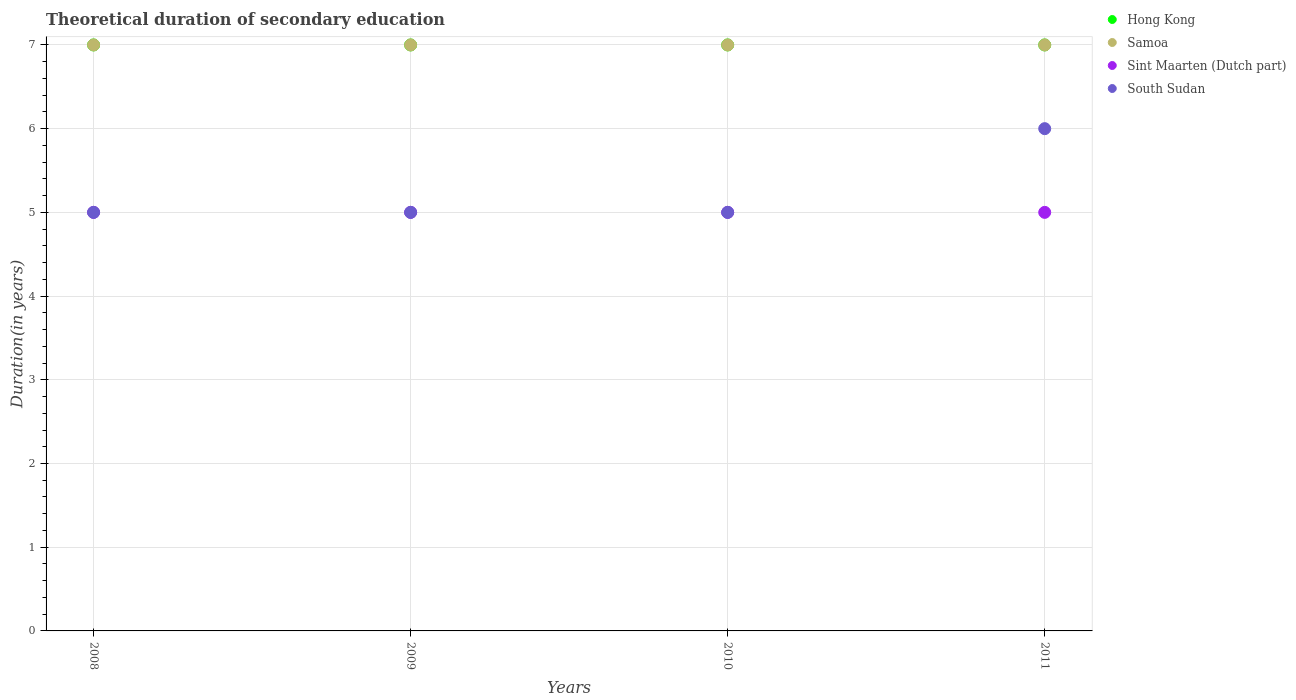Is the number of dotlines equal to the number of legend labels?
Make the answer very short. Yes. What is the total theoretical duration of secondary education in Sint Maarten (Dutch part) in 2011?
Make the answer very short. 5. Across all years, what is the maximum total theoretical duration of secondary education in South Sudan?
Offer a terse response. 6. What is the total total theoretical duration of secondary education in South Sudan in the graph?
Make the answer very short. 21. What is the difference between the total theoretical duration of secondary education in Sint Maarten (Dutch part) in 2011 and the total theoretical duration of secondary education in Samoa in 2009?
Ensure brevity in your answer.  -2. What is the average total theoretical duration of secondary education in South Sudan per year?
Offer a terse response. 5.25. In the year 2009, what is the difference between the total theoretical duration of secondary education in Sint Maarten (Dutch part) and total theoretical duration of secondary education in Samoa?
Give a very brief answer. -2. In how many years, is the total theoretical duration of secondary education in Sint Maarten (Dutch part) greater than 4.4 years?
Your answer should be compact. 4. What is the ratio of the total theoretical duration of secondary education in Sint Maarten (Dutch part) in 2010 to that in 2011?
Offer a terse response. 1. Is the difference between the total theoretical duration of secondary education in Sint Maarten (Dutch part) in 2008 and 2011 greater than the difference between the total theoretical duration of secondary education in Samoa in 2008 and 2011?
Offer a very short reply. No. What is the difference between the highest and the second highest total theoretical duration of secondary education in Samoa?
Keep it short and to the point. 0. In how many years, is the total theoretical duration of secondary education in Samoa greater than the average total theoretical duration of secondary education in Samoa taken over all years?
Give a very brief answer. 0. Is it the case that in every year, the sum of the total theoretical duration of secondary education in Hong Kong and total theoretical duration of secondary education in Samoa  is greater than the total theoretical duration of secondary education in Sint Maarten (Dutch part)?
Ensure brevity in your answer.  Yes. How many years are there in the graph?
Provide a short and direct response. 4. What is the difference between two consecutive major ticks on the Y-axis?
Make the answer very short. 1. Are the values on the major ticks of Y-axis written in scientific E-notation?
Your response must be concise. No. Does the graph contain grids?
Offer a very short reply. Yes. How are the legend labels stacked?
Your response must be concise. Vertical. What is the title of the graph?
Keep it short and to the point. Theoretical duration of secondary education. What is the label or title of the X-axis?
Offer a very short reply. Years. What is the label or title of the Y-axis?
Keep it short and to the point. Duration(in years). What is the Duration(in years) in South Sudan in 2008?
Keep it short and to the point. 5. What is the Duration(in years) of Hong Kong in 2010?
Your answer should be compact. 7. What is the Duration(in years) in South Sudan in 2010?
Offer a terse response. 5. What is the Duration(in years) of South Sudan in 2011?
Make the answer very short. 6. Across all years, what is the maximum Duration(in years) of Hong Kong?
Make the answer very short. 7. Across all years, what is the maximum Duration(in years) of Sint Maarten (Dutch part)?
Your answer should be very brief. 5. Across all years, what is the maximum Duration(in years) of South Sudan?
Your answer should be compact. 6. What is the difference between the Duration(in years) in Hong Kong in 2008 and that in 2009?
Your answer should be very brief. 0. What is the difference between the Duration(in years) in Samoa in 2008 and that in 2009?
Your response must be concise. 0. What is the difference between the Duration(in years) in South Sudan in 2008 and that in 2009?
Provide a succinct answer. 0. What is the difference between the Duration(in years) of Hong Kong in 2008 and that in 2010?
Your answer should be very brief. 0. What is the difference between the Duration(in years) of Sint Maarten (Dutch part) in 2008 and that in 2010?
Provide a succinct answer. 0. What is the difference between the Duration(in years) of Hong Kong in 2008 and that in 2011?
Provide a short and direct response. 0. What is the difference between the Duration(in years) of Sint Maarten (Dutch part) in 2008 and that in 2011?
Ensure brevity in your answer.  0. What is the difference between the Duration(in years) of Hong Kong in 2009 and that in 2010?
Your answer should be compact. 0. What is the difference between the Duration(in years) of Sint Maarten (Dutch part) in 2009 and that in 2010?
Ensure brevity in your answer.  0. What is the difference between the Duration(in years) in Samoa in 2009 and that in 2011?
Offer a very short reply. 0. What is the difference between the Duration(in years) of South Sudan in 2009 and that in 2011?
Offer a very short reply. -1. What is the difference between the Duration(in years) of Samoa in 2010 and that in 2011?
Ensure brevity in your answer.  0. What is the difference between the Duration(in years) of South Sudan in 2010 and that in 2011?
Your answer should be compact. -1. What is the difference between the Duration(in years) of Hong Kong in 2008 and the Duration(in years) of Samoa in 2009?
Keep it short and to the point. 0. What is the difference between the Duration(in years) in Sint Maarten (Dutch part) in 2008 and the Duration(in years) in South Sudan in 2009?
Provide a short and direct response. 0. What is the difference between the Duration(in years) of Sint Maarten (Dutch part) in 2008 and the Duration(in years) of South Sudan in 2010?
Keep it short and to the point. 0. What is the difference between the Duration(in years) of Hong Kong in 2008 and the Duration(in years) of South Sudan in 2011?
Your answer should be very brief. 1. What is the difference between the Duration(in years) of Samoa in 2008 and the Duration(in years) of Sint Maarten (Dutch part) in 2011?
Your answer should be compact. 2. What is the difference between the Duration(in years) of Samoa in 2008 and the Duration(in years) of South Sudan in 2011?
Provide a succinct answer. 1. What is the difference between the Duration(in years) in Sint Maarten (Dutch part) in 2008 and the Duration(in years) in South Sudan in 2011?
Offer a very short reply. -1. What is the difference between the Duration(in years) of Hong Kong in 2009 and the Duration(in years) of Samoa in 2010?
Give a very brief answer. 0. What is the difference between the Duration(in years) of Hong Kong in 2009 and the Duration(in years) of Sint Maarten (Dutch part) in 2010?
Provide a short and direct response. 2. What is the difference between the Duration(in years) in Hong Kong in 2009 and the Duration(in years) in South Sudan in 2010?
Your answer should be very brief. 2. What is the difference between the Duration(in years) of Samoa in 2009 and the Duration(in years) of Sint Maarten (Dutch part) in 2010?
Your answer should be very brief. 2. What is the difference between the Duration(in years) of Samoa in 2009 and the Duration(in years) of South Sudan in 2010?
Offer a terse response. 2. What is the difference between the Duration(in years) of Hong Kong in 2009 and the Duration(in years) of Samoa in 2011?
Your answer should be very brief. 0. What is the difference between the Duration(in years) in Hong Kong in 2009 and the Duration(in years) in Sint Maarten (Dutch part) in 2011?
Ensure brevity in your answer.  2. What is the difference between the Duration(in years) of Sint Maarten (Dutch part) in 2009 and the Duration(in years) of South Sudan in 2011?
Your response must be concise. -1. What is the difference between the Duration(in years) of Hong Kong in 2010 and the Duration(in years) of Samoa in 2011?
Give a very brief answer. 0. What is the difference between the Duration(in years) in Hong Kong in 2010 and the Duration(in years) in Sint Maarten (Dutch part) in 2011?
Your answer should be very brief. 2. What is the difference between the Duration(in years) in Samoa in 2010 and the Duration(in years) in South Sudan in 2011?
Your answer should be very brief. 1. What is the average Duration(in years) of Hong Kong per year?
Provide a succinct answer. 7. What is the average Duration(in years) in Samoa per year?
Make the answer very short. 7. What is the average Duration(in years) of South Sudan per year?
Ensure brevity in your answer.  5.25. In the year 2008, what is the difference between the Duration(in years) of Hong Kong and Duration(in years) of Samoa?
Provide a short and direct response. 0. In the year 2008, what is the difference between the Duration(in years) of Hong Kong and Duration(in years) of Sint Maarten (Dutch part)?
Provide a short and direct response. 2. In the year 2008, what is the difference between the Duration(in years) in Samoa and Duration(in years) in Sint Maarten (Dutch part)?
Your answer should be very brief. 2. In the year 2008, what is the difference between the Duration(in years) of Samoa and Duration(in years) of South Sudan?
Give a very brief answer. 2. In the year 2009, what is the difference between the Duration(in years) of Hong Kong and Duration(in years) of South Sudan?
Ensure brevity in your answer.  2. In the year 2009, what is the difference between the Duration(in years) in Samoa and Duration(in years) in South Sudan?
Your answer should be very brief. 2. In the year 2009, what is the difference between the Duration(in years) of Sint Maarten (Dutch part) and Duration(in years) of South Sudan?
Offer a very short reply. 0. In the year 2010, what is the difference between the Duration(in years) of Hong Kong and Duration(in years) of Samoa?
Provide a succinct answer. 0. In the year 2010, what is the difference between the Duration(in years) in Hong Kong and Duration(in years) in Sint Maarten (Dutch part)?
Keep it short and to the point. 2. In the year 2011, what is the difference between the Duration(in years) of Hong Kong and Duration(in years) of Sint Maarten (Dutch part)?
Provide a succinct answer. 2. What is the ratio of the Duration(in years) of Hong Kong in 2008 to that in 2009?
Give a very brief answer. 1. What is the ratio of the Duration(in years) of Sint Maarten (Dutch part) in 2008 to that in 2009?
Ensure brevity in your answer.  1. What is the ratio of the Duration(in years) of South Sudan in 2008 to that in 2009?
Provide a succinct answer. 1. What is the ratio of the Duration(in years) in Hong Kong in 2008 to that in 2010?
Provide a succinct answer. 1. What is the ratio of the Duration(in years) of Hong Kong in 2008 to that in 2011?
Provide a short and direct response. 1. What is the ratio of the Duration(in years) in Samoa in 2008 to that in 2011?
Ensure brevity in your answer.  1. What is the ratio of the Duration(in years) in Sint Maarten (Dutch part) in 2008 to that in 2011?
Your answer should be very brief. 1. What is the ratio of the Duration(in years) of South Sudan in 2008 to that in 2011?
Keep it short and to the point. 0.83. What is the ratio of the Duration(in years) of Hong Kong in 2009 to that in 2010?
Offer a terse response. 1. What is the ratio of the Duration(in years) in Sint Maarten (Dutch part) in 2009 to that in 2010?
Offer a terse response. 1. What is the ratio of the Duration(in years) of Samoa in 2009 to that in 2011?
Give a very brief answer. 1. What is the ratio of the Duration(in years) of Sint Maarten (Dutch part) in 2010 to that in 2011?
Your answer should be compact. 1. What is the difference between the highest and the second highest Duration(in years) in Samoa?
Make the answer very short. 0. What is the difference between the highest and the second highest Duration(in years) in South Sudan?
Offer a very short reply. 1. What is the difference between the highest and the lowest Duration(in years) in Hong Kong?
Offer a very short reply. 0. What is the difference between the highest and the lowest Duration(in years) of Sint Maarten (Dutch part)?
Your answer should be very brief. 0. What is the difference between the highest and the lowest Duration(in years) of South Sudan?
Provide a short and direct response. 1. 